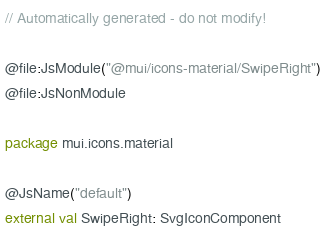<code> <loc_0><loc_0><loc_500><loc_500><_Kotlin_>// Automatically generated - do not modify!

@file:JsModule("@mui/icons-material/SwipeRight")
@file:JsNonModule

package mui.icons.material

@JsName("default")
external val SwipeRight: SvgIconComponent
</code> 